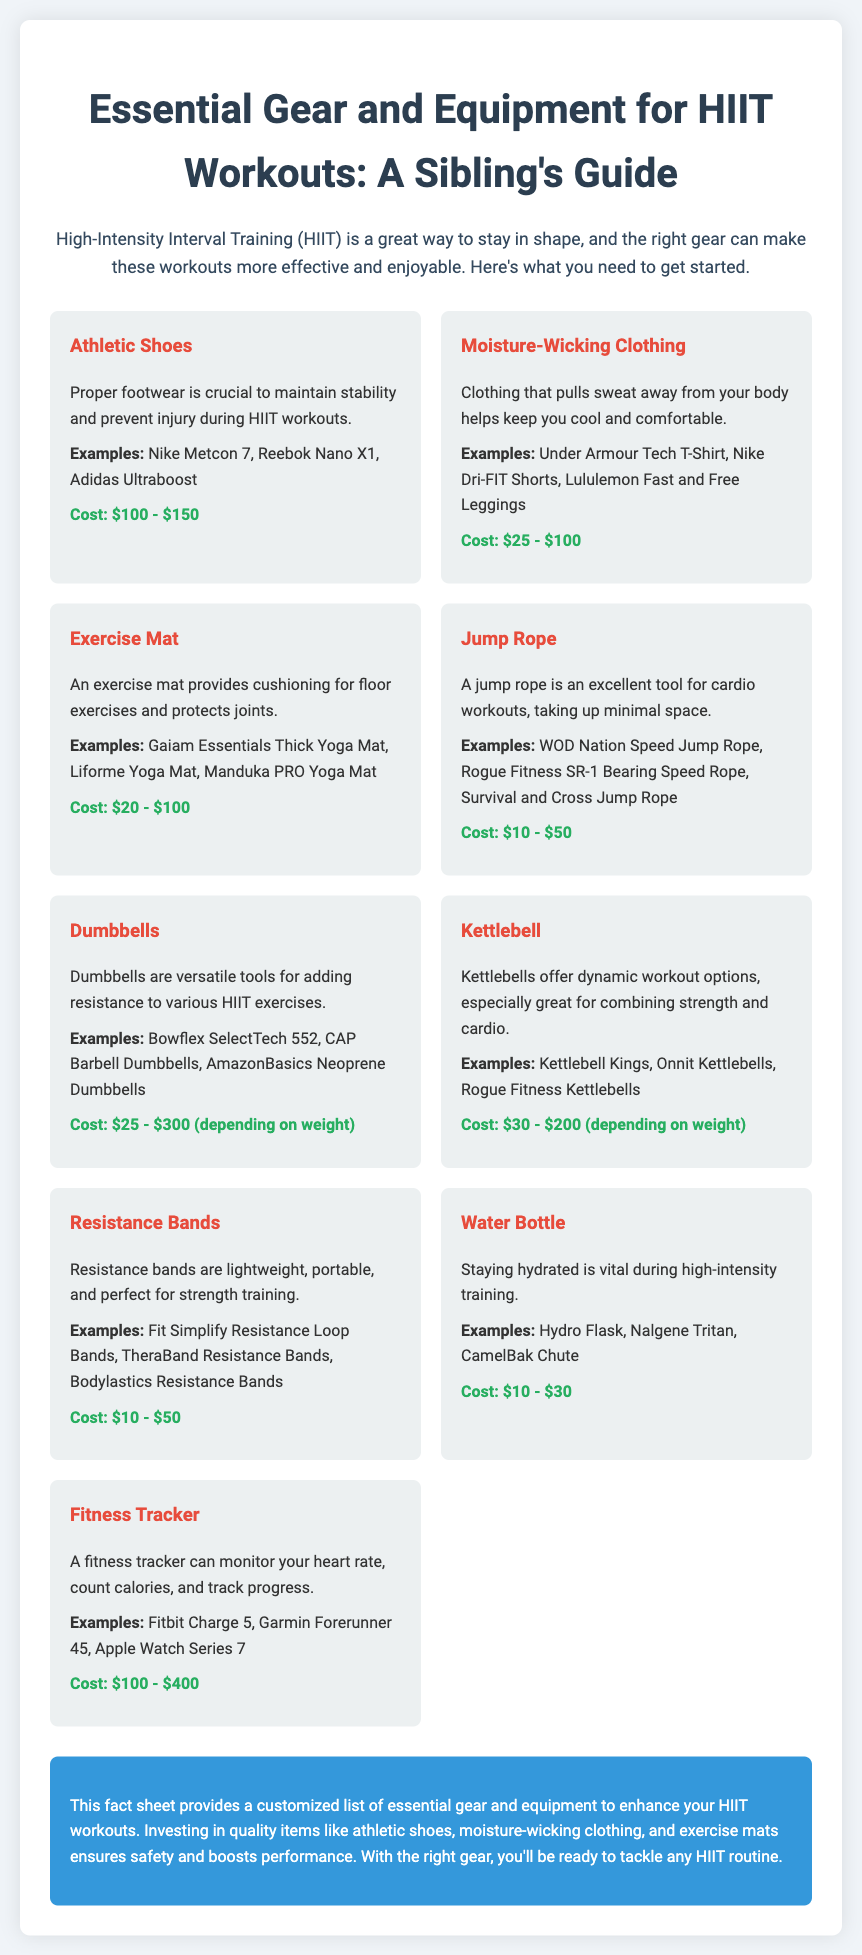what is the cost range for Athletic Shoes? Athletic Shoes cost between $100 and $150 according to the document.
Answer: $100 - $150 what is the main benefit of Moisture-Wicking Clothing? The document states that it helps keep you cool and comfortable by pulling sweat away from the body.
Answer: Keeps you cool and comfortable what is an example of a Fitness Tracker mentioned? The document lists Fitbit Charge 5 as an example of a Fitness Tracker.
Answer: Fitbit Charge 5 which item offers dynamic workout options and combines strength and cardio? The Kettlebell is mentioned as suitable for dynamic workouts that combine strength and cardio.
Answer: Kettlebell how much do Resistance Bands typically cost? The cost range for Resistance Bands is specified as $10 to $50 in the document.
Answer: $10 - $50 what is a crucial item for maintaining stability during HIIT workouts? The document highlights Athletic Shoes as crucial for stability and preventing injury.
Answer: Athletic Shoes which gear is designed to monitor heart rate and track progress? A Fitness Tracker is designed for monitoring heart rate and tracking progress according to the document.
Answer: Fitness Tracker what is the purpose of an Exercise Mat in HIIT workouts? The document explains that an Exercise Mat provides cushioning and protects joints during floor exercises.
Answer: Provides cushioning and protects joints what does the summary emphasize as important for HIIT workouts? The summary emphasizes investing in quality items like athletic shoes and exercise mats to enhance performance.
Answer: Investing in quality items 